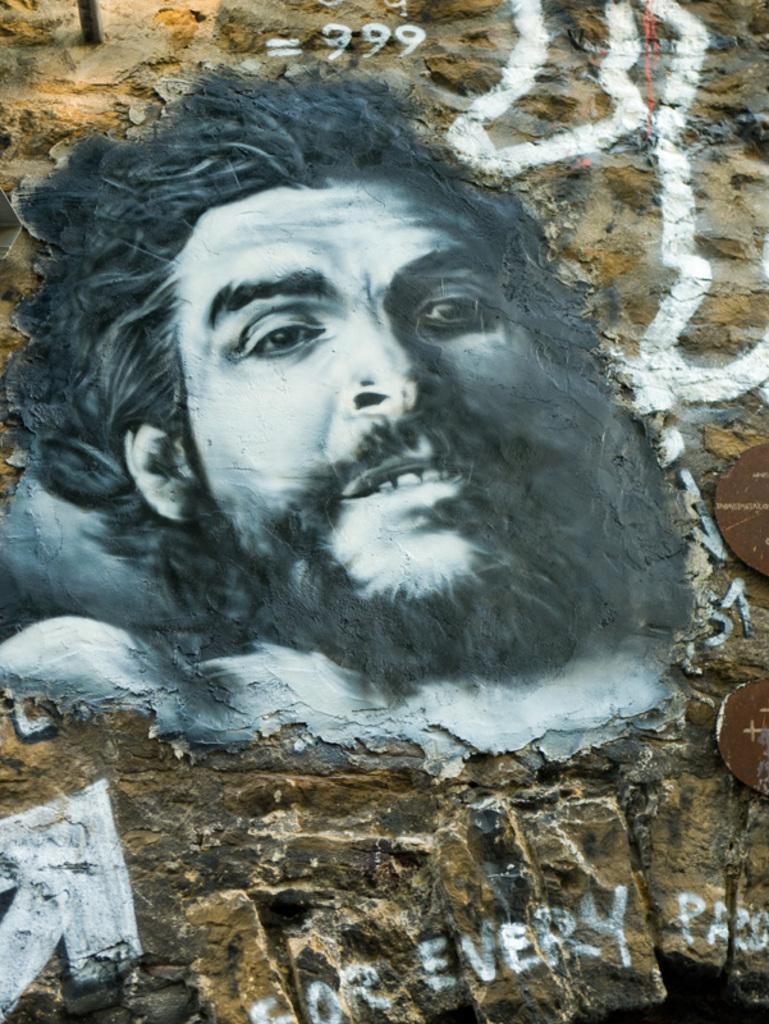Please provide a concise description of this image. In this image I can see a huge wall which is made up of rocks and on the wall I can see a painting of a person's face which is white and black in color. 